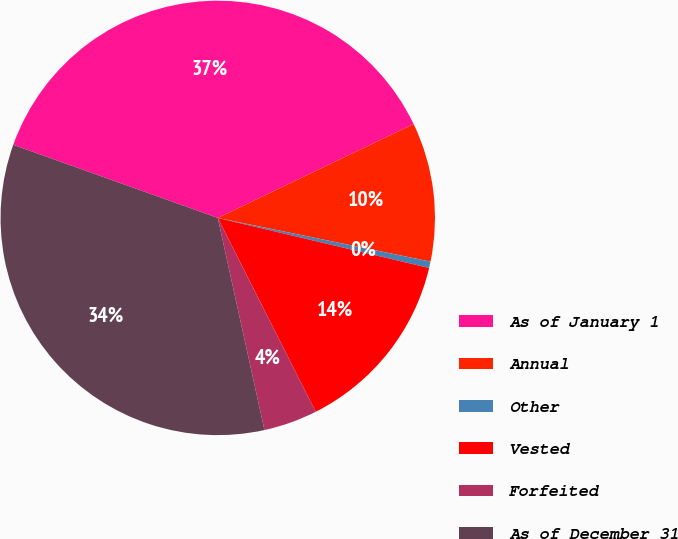Convert chart. <chart><loc_0><loc_0><loc_500><loc_500><pie_chart><fcel>As of January 1<fcel>Annual<fcel>Other<fcel>Vested<fcel>Forfeited<fcel>As of December 31<nl><fcel>37.42%<fcel>10.34%<fcel>0.48%<fcel>13.85%<fcel>4.0%<fcel>33.91%<nl></chart> 